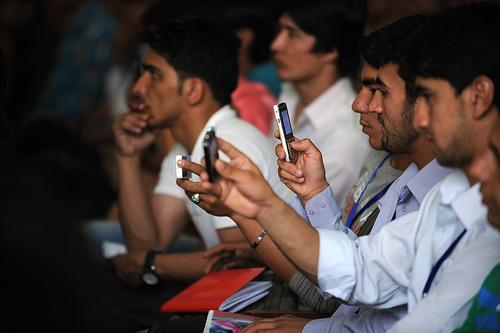Describe one pattern or anomaly you can notice in this image. An anomaly noticed in the image is that the man with the dark beard is looking straight ahead, not engaging with the event like the others. What item is held by various men in the image? Several men in the image are holding cell phones. Describe the appearance of the man who's holding his chin in the image. The man holding his chin has black hair, light skin, facial hair and is wearing a rolled-up sleeve. What kind of sentiment or atmosphere can you sense from the image? The atmosphere in the image feels professional, attentive, and engaged in the conference or talk. Can you provide a brief analysis of the context within the image? The image shows a group of men assembled in a conference room, listening to a guest speaker, and some of them are holding cellphones to take pictures or document the event. What is the color of the notebook in the image and what is its context? The notebook is red color and is a part of an orange folder with items in it. What color is the watch on the man's wrist? The watch on the man's wrist is silver and black color. What color is the ring visible in the image, and on which body part is it worn? The ring is silver color and is worn on the finger. Identify the main activity taking place in the image. Men gathered in a conference room, some of them holding cell phones and taking pictures of the guest speaker. Can you describe the object on man's hand that's resting on his chin? The man has his fingers resting on his chin, possibly listening or thinking. Is the man holding a purple cellphone? No, it's not mentioned in the image. Does the cellphone screen appear to be on? Yes, the cellphone screen is on. Are the men holding pink cellphones? The instruction refers to men holding cellphones. While the original captions mention "three cellphones in mens hands," "three men holding cellphones," and similar phrases, the color of the cellphones is neither specified nor mentioned as pink. Which person is wearing a silver wristwatch? Describe their location in the image. The man wearing the silver wristwatch is at coordinates X:144 Y:247. How many mobiles are seen in the image and what are their colors? Three mobiles are seen: one black cellphone and two white cellphones. Can you detect any text in the image? No text is detected in the image. Describe the scene in terms of the number of people present. There are seven people seen in the scene. What is the overall sentiment of the people in the image? The overall sentiment appears to be engaged and attentive. Find any instances of anomalies or unusual objects in the image. No notable anomalies or unusual objects are detected. What is the sentiment of the "men holding cellphones in front of faces"? They are focused and attentive. Is the man's shirt sleeve green and covered in polka dots? The original captions mention a "rolled up sleeve on the arm," but they do not mention any color or pattern attributes as described in the instruction. Thus, specifying the sleeve as green and covered in polka dots is misleading. Can you see a yellow wristwatch on the man's wrist? The instruction refers to a wristwatch, which is mentioned as "a silver watch on mans wrist" in the original captions, but the color attribute is wrong. The watch is silver, not yellow. What are the people in the room doing? People are sitting in chairs, listening to a speaker, and taking pictures with their cellphones. Please identify all men who are holding cell phones. There are three men holding cell phones. Describe the appearance of the man with dark hair looking straight ahead. He has dark hair, light skin, and black facial hair. Based on the image, which person is most likely the guest speaker? It is unclear which person is the guest speaker. What is the color of the notebook in the image? The notebook is red in color. What is the color of the object that the man's hand is resting on? The man's hand is resting on his chin. Describe the quality of the image. The image quality is clear and well-defined. Is the tag on the man's shirt bright red and shaped like a star? The original captions have "tag is blue color", so specifying a star-shaped bright red tag in the instruction is misleading and contradicts the existing information. What color is the wristwatch on the man's wrist? The wristwatch is silver. How would you describe the man's facial hair in the image? The man has a dark beard. What is the color of the ring on the man's finger? The ring is silver in color. How many buttons are there on the man's shirt cuff? There are two buttons on the man's shirt cuff. 